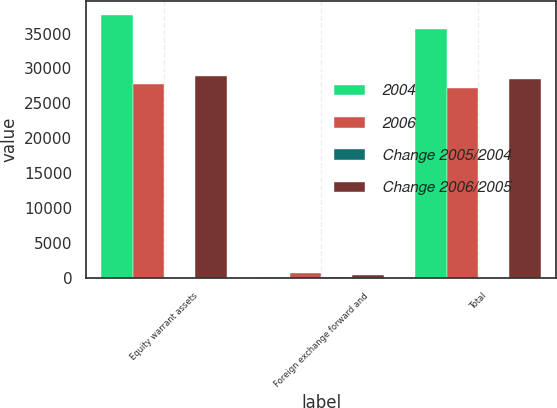Convert chart. <chart><loc_0><loc_0><loc_500><loc_500><stacked_bar_chart><ecel><fcel>Equity warrant assets<fcel>Foreign exchange forward and<fcel>Total<nl><fcel>2004<fcel>37725<fcel>164<fcel>35671<nl><fcel>2006<fcel>27802<fcel>766<fcel>27254<nl><fcel>Change 2005/2004<fcel>35.7<fcel>121.4<fcel>30.9<nl><fcel>Change 2006/2005<fcel>28928<fcel>431<fcel>28546<nl></chart> 